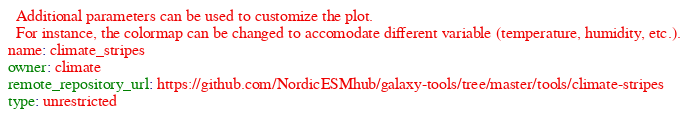Convert code to text. <code><loc_0><loc_0><loc_500><loc_500><_YAML_>  Additional parameters can be used to customize the plot.
  For instance, the colormap can be changed to accomodate different variable (temperature, humidity, etc.).
name: climate_stripes
owner: climate
remote_repository_url: https://github.com/NordicESMhub/galaxy-tools/tree/master/tools/climate-stripes
type: unrestricted
</code> 